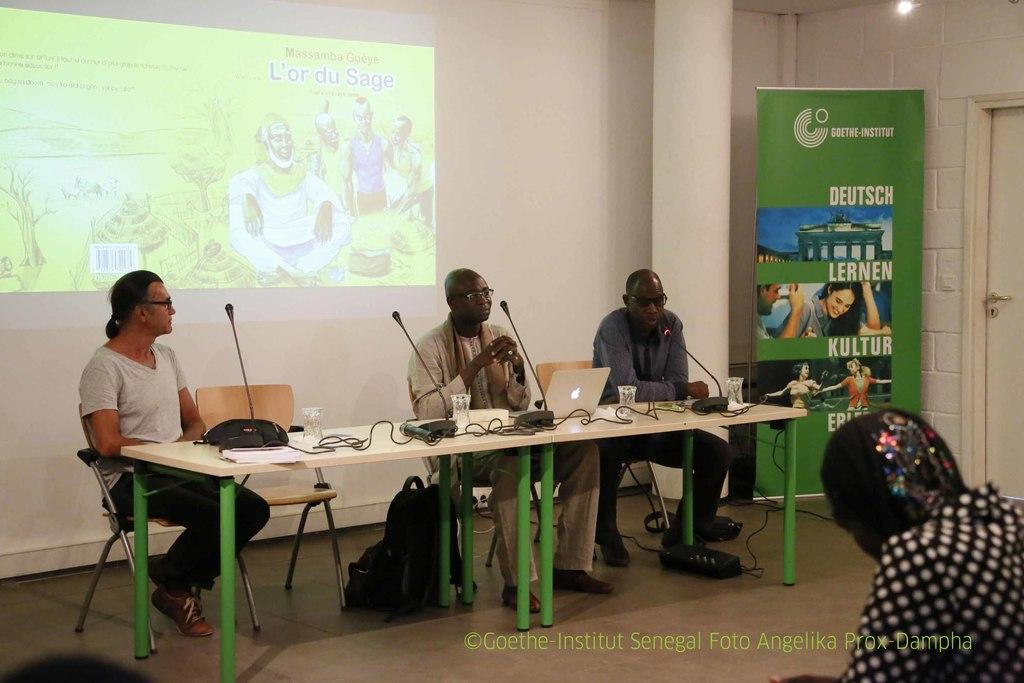Who or what can be seen in the image? There are people in the image. What are the people doing in the image? The people are sitting on chairs. What letter is being used as a chair in the image? There is no letter being used as a chair in the image; the people are sitting on regular chairs. 